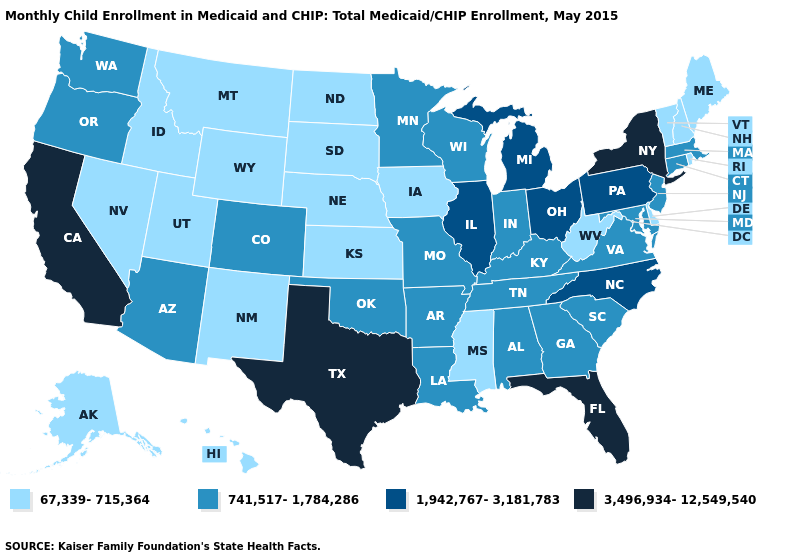What is the highest value in the USA?
Write a very short answer. 3,496,934-12,549,540. What is the value of North Dakota?
Short answer required. 67,339-715,364. Name the states that have a value in the range 1,942,767-3,181,783?
Write a very short answer. Illinois, Michigan, North Carolina, Ohio, Pennsylvania. Which states have the highest value in the USA?
Give a very brief answer. California, Florida, New York, Texas. What is the highest value in states that border Wyoming?
Be succinct. 741,517-1,784,286. Name the states that have a value in the range 67,339-715,364?
Give a very brief answer. Alaska, Delaware, Hawaii, Idaho, Iowa, Kansas, Maine, Mississippi, Montana, Nebraska, Nevada, New Hampshire, New Mexico, North Dakota, Rhode Island, South Dakota, Utah, Vermont, West Virginia, Wyoming. What is the value of Delaware?
Be succinct. 67,339-715,364. Which states have the highest value in the USA?
Write a very short answer. California, Florida, New York, Texas. Does California have the highest value in the West?
Write a very short answer. Yes. What is the lowest value in the West?
Answer briefly. 67,339-715,364. What is the value of Kansas?
Short answer required. 67,339-715,364. Does Hawaii have a lower value than Alaska?
Keep it brief. No. Is the legend a continuous bar?
Short answer required. No. What is the value of New Jersey?
Give a very brief answer. 741,517-1,784,286. Does New York have the lowest value in the USA?
Answer briefly. No. 